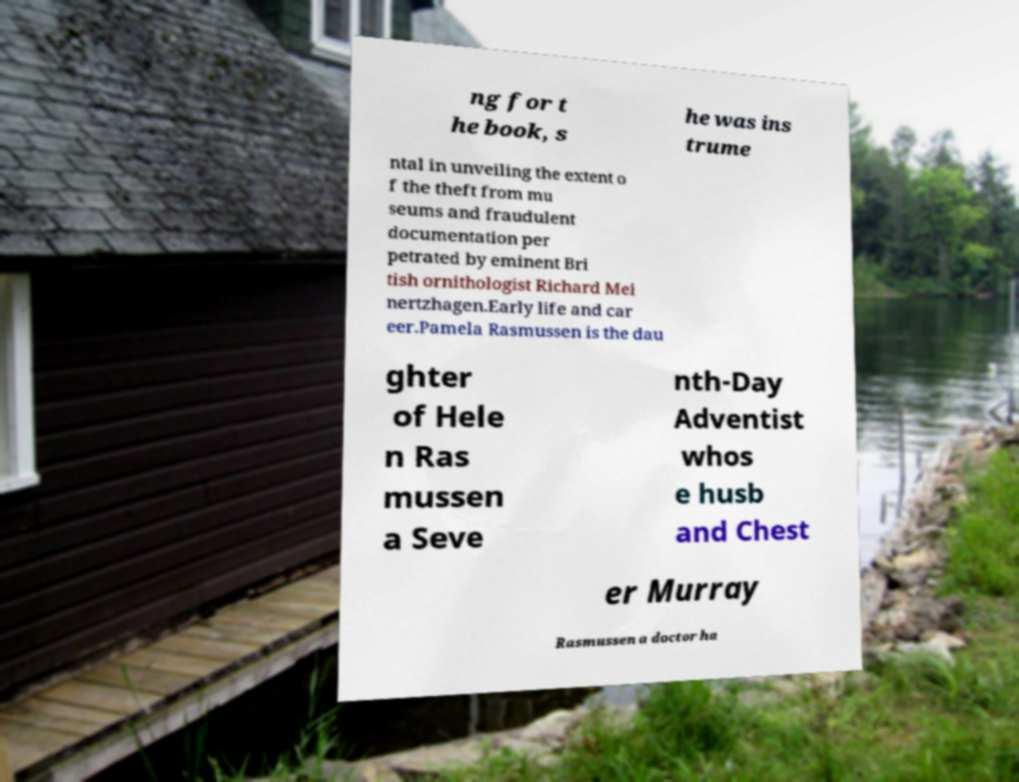Please read and relay the text visible in this image. What does it say? ng for t he book, s he was ins trume ntal in unveiling the extent o f the theft from mu seums and fraudulent documentation per petrated by eminent Bri tish ornithologist Richard Mei nertzhagen.Early life and car eer.Pamela Rasmussen is the dau ghter of Hele n Ras mussen a Seve nth-Day Adventist whos e husb and Chest er Murray Rasmussen a doctor ha 